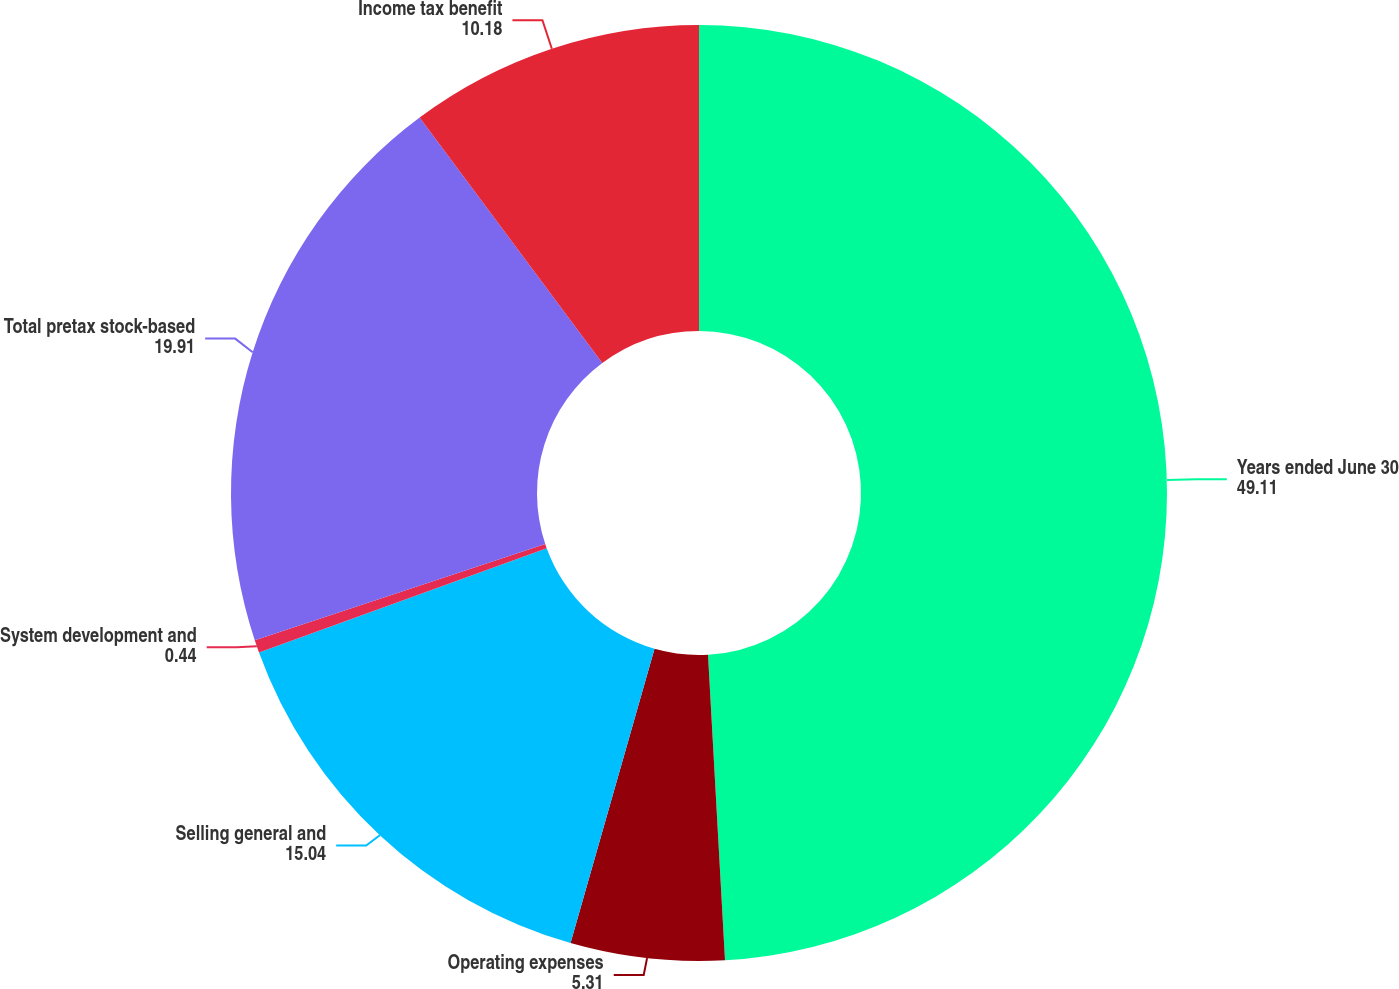Convert chart to OTSL. <chart><loc_0><loc_0><loc_500><loc_500><pie_chart><fcel>Years ended June 30<fcel>Operating expenses<fcel>Selling general and<fcel>System development and<fcel>Total pretax stock-based<fcel>Income tax benefit<nl><fcel>49.11%<fcel>5.31%<fcel>15.04%<fcel>0.44%<fcel>19.91%<fcel>10.18%<nl></chart> 